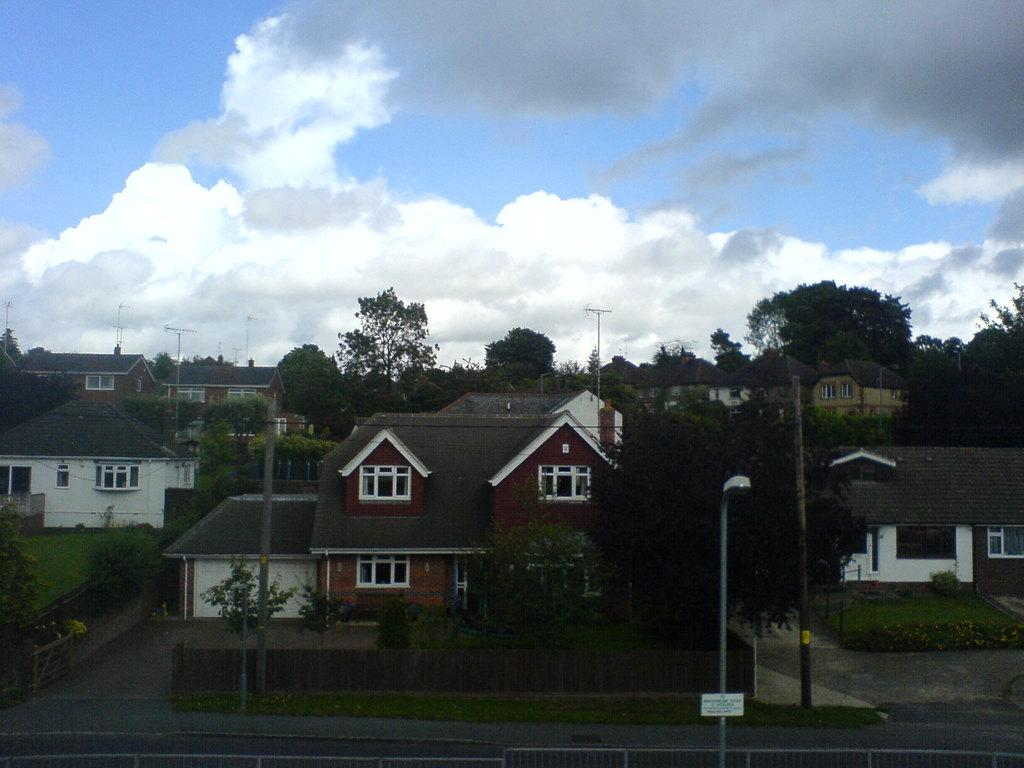What type of structures can be seen in the image? There are houses in the image. What other natural elements are present in the image? There are trees in the image. What man-made objects can be seen in the image? There are poles and fences in the image. What is the main pathway for vehicles or pedestrians in the image? There is a road in the image. What is the condition of the sky in the image? The sky is visible in the image, and it appears to be cloudy. What type of soda is being served at the house in the image? There is no soda present in the image, and no indication of any beverages being served. What part of the human body can be seen interacting with the fences in the image? There are no human body parts visible in the image, as it only features houses, trees, poles, fences, a road, and a cloudy sky. 